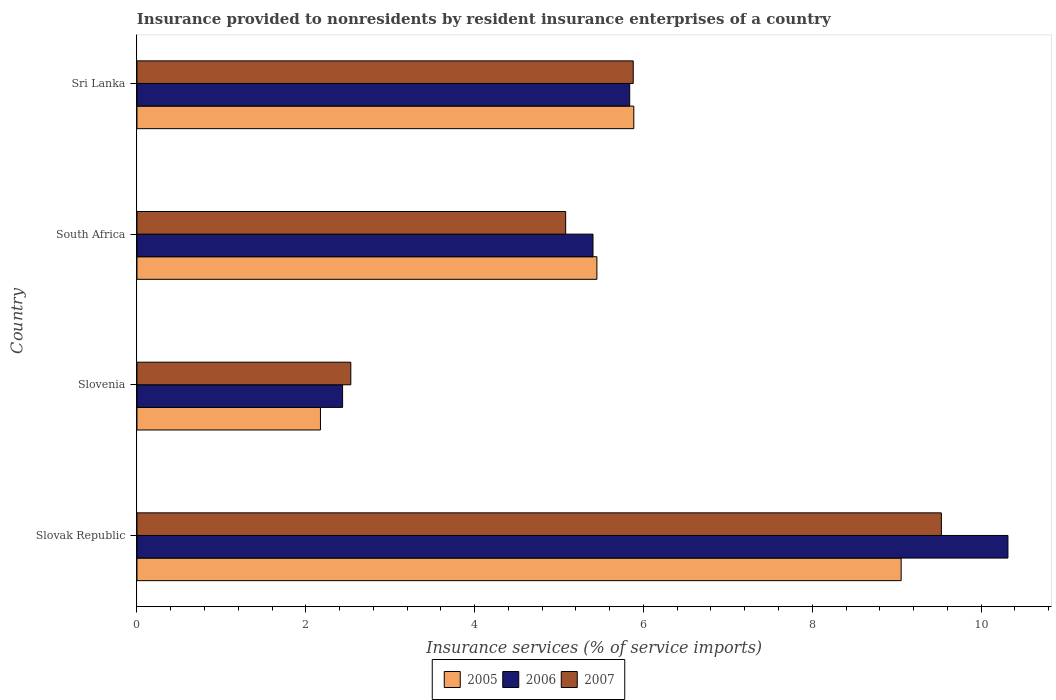How many groups of bars are there?
Your answer should be very brief. 4. How many bars are there on the 1st tick from the top?
Keep it short and to the point. 3. What is the label of the 4th group of bars from the top?
Your answer should be very brief. Slovak Republic. What is the insurance provided to nonresidents in 2006 in South Africa?
Keep it short and to the point. 5.4. Across all countries, what is the maximum insurance provided to nonresidents in 2005?
Offer a terse response. 9.05. Across all countries, what is the minimum insurance provided to nonresidents in 2005?
Make the answer very short. 2.17. In which country was the insurance provided to nonresidents in 2006 maximum?
Your response must be concise. Slovak Republic. In which country was the insurance provided to nonresidents in 2006 minimum?
Ensure brevity in your answer.  Slovenia. What is the total insurance provided to nonresidents in 2007 in the graph?
Keep it short and to the point. 23.02. What is the difference between the insurance provided to nonresidents in 2005 in Slovenia and that in South Africa?
Ensure brevity in your answer.  -3.27. What is the difference between the insurance provided to nonresidents in 2005 in Sri Lanka and the insurance provided to nonresidents in 2006 in South Africa?
Your answer should be compact. 0.48. What is the average insurance provided to nonresidents in 2005 per country?
Keep it short and to the point. 5.64. What is the difference between the insurance provided to nonresidents in 2006 and insurance provided to nonresidents in 2007 in South Africa?
Offer a terse response. 0.32. What is the ratio of the insurance provided to nonresidents in 2006 in Slovak Republic to that in South Africa?
Provide a succinct answer. 1.91. Is the insurance provided to nonresidents in 2006 in Slovenia less than that in South Africa?
Provide a succinct answer. Yes. What is the difference between the highest and the second highest insurance provided to nonresidents in 2006?
Offer a very short reply. 4.48. What is the difference between the highest and the lowest insurance provided to nonresidents in 2007?
Provide a succinct answer. 7. In how many countries, is the insurance provided to nonresidents in 2005 greater than the average insurance provided to nonresidents in 2005 taken over all countries?
Provide a short and direct response. 2. What does the 2nd bar from the top in Slovak Republic represents?
Offer a very short reply. 2006. What does the 3rd bar from the bottom in Slovenia represents?
Ensure brevity in your answer.  2007. Is it the case that in every country, the sum of the insurance provided to nonresidents in 2005 and insurance provided to nonresidents in 2006 is greater than the insurance provided to nonresidents in 2007?
Make the answer very short. Yes. How many bars are there?
Make the answer very short. 12. How many countries are there in the graph?
Provide a succinct answer. 4. Are the values on the major ticks of X-axis written in scientific E-notation?
Make the answer very short. No. Does the graph contain grids?
Give a very brief answer. No. Where does the legend appear in the graph?
Keep it short and to the point. Bottom center. How are the legend labels stacked?
Your answer should be very brief. Horizontal. What is the title of the graph?
Your answer should be compact. Insurance provided to nonresidents by resident insurance enterprises of a country. Does "2012" appear as one of the legend labels in the graph?
Your response must be concise. No. What is the label or title of the X-axis?
Provide a succinct answer. Insurance services (% of service imports). What is the Insurance services (% of service imports) of 2005 in Slovak Republic?
Your answer should be compact. 9.05. What is the Insurance services (% of service imports) of 2006 in Slovak Republic?
Keep it short and to the point. 10.32. What is the Insurance services (% of service imports) in 2007 in Slovak Republic?
Ensure brevity in your answer.  9.53. What is the Insurance services (% of service imports) of 2005 in Slovenia?
Provide a short and direct response. 2.17. What is the Insurance services (% of service imports) in 2006 in Slovenia?
Make the answer very short. 2.44. What is the Insurance services (% of service imports) of 2007 in Slovenia?
Your answer should be compact. 2.53. What is the Insurance services (% of service imports) in 2005 in South Africa?
Provide a short and direct response. 5.45. What is the Insurance services (% of service imports) in 2006 in South Africa?
Make the answer very short. 5.4. What is the Insurance services (% of service imports) in 2007 in South Africa?
Provide a short and direct response. 5.08. What is the Insurance services (% of service imports) in 2005 in Sri Lanka?
Provide a succinct answer. 5.89. What is the Insurance services (% of service imports) in 2006 in Sri Lanka?
Keep it short and to the point. 5.84. What is the Insurance services (% of service imports) of 2007 in Sri Lanka?
Give a very brief answer. 5.88. Across all countries, what is the maximum Insurance services (% of service imports) of 2005?
Ensure brevity in your answer.  9.05. Across all countries, what is the maximum Insurance services (% of service imports) in 2006?
Give a very brief answer. 10.32. Across all countries, what is the maximum Insurance services (% of service imports) in 2007?
Your answer should be very brief. 9.53. Across all countries, what is the minimum Insurance services (% of service imports) in 2005?
Your answer should be compact. 2.17. Across all countries, what is the minimum Insurance services (% of service imports) in 2006?
Keep it short and to the point. 2.44. Across all countries, what is the minimum Insurance services (% of service imports) of 2007?
Your response must be concise. 2.53. What is the total Insurance services (% of service imports) in 2005 in the graph?
Make the answer very short. 22.56. What is the total Insurance services (% of service imports) of 2006 in the graph?
Ensure brevity in your answer.  24. What is the total Insurance services (% of service imports) of 2007 in the graph?
Provide a short and direct response. 23.02. What is the difference between the Insurance services (% of service imports) in 2005 in Slovak Republic and that in Slovenia?
Your answer should be very brief. 6.88. What is the difference between the Insurance services (% of service imports) in 2006 in Slovak Republic and that in Slovenia?
Keep it short and to the point. 7.88. What is the difference between the Insurance services (% of service imports) in 2007 in Slovak Republic and that in Slovenia?
Give a very brief answer. 7. What is the difference between the Insurance services (% of service imports) in 2005 in Slovak Republic and that in South Africa?
Your answer should be very brief. 3.6. What is the difference between the Insurance services (% of service imports) in 2006 in Slovak Republic and that in South Africa?
Offer a very short reply. 4.92. What is the difference between the Insurance services (% of service imports) of 2007 in Slovak Republic and that in South Africa?
Your response must be concise. 4.45. What is the difference between the Insurance services (% of service imports) of 2005 in Slovak Republic and that in Sri Lanka?
Ensure brevity in your answer.  3.17. What is the difference between the Insurance services (% of service imports) of 2006 in Slovak Republic and that in Sri Lanka?
Ensure brevity in your answer.  4.48. What is the difference between the Insurance services (% of service imports) of 2007 in Slovak Republic and that in Sri Lanka?
Provide a short and direct response. 3.65. What is the difference between the Insurance services (% of service imports) of 2005 in Slovenia and that in South Africa?
Offer a terse response. -3.27. What is the difference between the Insurance services (% of service imports) in 2006 in Slovenia and that in South Africa?
Keep it short and to the point. -2.97. What is the difference between the Insurance services (% of service imports) in 2007 in Slovenia and that in South Africa?
Provide a succinct answer. -2.55. What is the difference between the Insurance services (% of service imports) of 2005 in Slovenia and that in Sri Lanka?
Offer a very short reply. -3.71. What is the difference between the Insurance services (% of service imports) of 2006 in Slovenia and that in Sri Lanka?
Ensure brevity in your answer.  -3.4. What is the difference between the Insurance services (% of service imports) of 2007 in Slovenia and that in Sri Lanka?
Your response must be concise. -3.35. What is the difference between the Insurance services (% of service imports) in 2005 in South Africa and that in Sri Lanka?
Provide a short and direct response. -0.44. What is the difference between the Insurance services (% of service imports) in 2006 in South Africa and that in Sri Lanka?
Give a very brief answer. -0.43. What is the difference between the Insurance services (% of service imports) of 2007 in South Africa and that in Sri Lanka?
Provide a succinct answer. -0.8. What is the difference between the Insurance services (% of service imports) in 2005 in Slovak Republic and the Insurance services (% of service imports) in 2006 in Slovenia?
Your answer should be very brief. 6.62. What is the difference between the Insurance services (% of service imports) in 2005 in Slovak Republic and the Insurance services (% of service imports) in 2007 in Slovenia?
Provide a short and direct response. 6.52. What is the difference between the Insurance services (% of service imports) in 2006 in Slovak Republic and the Insurance services (% of service imports) in 2007 in Slovenia?
Provide a short and direct response. 7.79. What is the difference between the Insurance services (% of service imports) in 2005 in Slovak Republic and the Insurance services (% of service imports) in 2006 in South Africa?
Provide a short and direct response. 3.65. What is the difference between the Insurance services (% of service imports) in 2005 in Slovak Republic and the Insurance services (% of service imports) in 2007 in South Africa?
Provide a short and direct response. 3.97. What is the difference between the Insurance services (% of service imports) in 2006 in Slovak Republic and the Insurance services (% of service imports) in 2007 in South Africa?
Your response must be concise. 5.24. What is the difference between the Insurance services (% of service imports) in 2005 in Slovak Republic and the Insurance services (% of service imports) in 2006 in Sri Lanka?
Provide a short and direct response. 3.22. What is the difference between the Insurance services (% of service imports) in 2005 in Slovak Republic and the Insurance services (% of service imports) in 2007 in Sri Lanka?
Give a very brief answer. 3.17. What is the difference between the Insurance services (% of service imports) in 2006 in Slovak Republic and the Insurance services (% of service imports) in 2007 in Sri Lanka?
Your response must be concise. 4.44. What is the difference between the Insurance services (% of service imports) of 2005 in Slovenia and the Insurance services (% of service imports) of 2006 in South Africa?
Your answer should be compact. -3.23. What is the difference between the Insurance services (% of service imports) in 2005 in Slovenia and the Insurance services (% of service imports) in 2007 in South Africa?
Offer a very short reply. -2.9. What is the difference between the Insurance services (% of service imports) in 2006 in Slovenia and the Insurance services (% of service imports) in 2007 in South Africa?
Ensure brevity in your answer.  -2.64. What is the difference between the Insurance services (% of service imports) of 2005 in Slovenia and the Insurance services (% of service imports) of 2006 in Sri Lanka?
Keep it short and to the point. -3.66. What is the difference between the Insurance services (% of service imports) in 2005 in Slovenia and the Insurance services (% of service imports) in 2007 in Sri Lanka?
Your answer should be compact. -3.71. What is the difference between the Insurance services (% of service imports) of 2006 in Slovenia and the Insurance services (% of service imports) of 2007 in Sri Lanka?
Your response must be concise. -3.44. What is the difference between the Insurance services (% of service imports) of 2005 in South Africa and the Insurance services (% of service imports) of 2006 in Sri Lanka?
Offer a terse response. -0.39. What is the difference between the Insurance services (% of service imports) of 2005 in South Africa and the Insurance services (% of service imports) of 2007 in Sri Lanka?
Make the answer very short. -0.43. What is the difference between the Insurance services (% of service imports) of 2006 in South Africa and the Insurance services (% of service imports) of 2007 in Sri Lanka?
Give a very brief answer. -0.48. What is the average Insurance services (% of service imports) of 2005 per country?
Your response must be concise. 5.64. What is the average Insurance services (% of service imports) in 2006 per country?
Your answer should be compact. 6. What is the average Insurance services (% of service imports) in 2007 per country?
Ensure brevity in your answer.  5.76. What is the difference between the Insurance services (% of service imports) in 2005 and Insurance services (% of service imports) in 2006 in Slovak Republic?
Make the answer very short. -1.27. What is the difference between the Insurance services (% of service imports) of 2005 and Insurance services (% of service imports) of 2007 in Slovak Republic?
Your answer should be very brief. -0.48. What is the difference between the Insurance services (% of service imports) in 2006 and Insurance services (% of service imports) in 2007 in Slovak Republic?
Keep it short and to the point. 0.79. What is the difference between the Insurance services (% of service imports) in 2005 and Insurance services (% of service imports) in 2006 in Slovenia?
Your answer should be compact. -0.26. What is the difference between the Insurance services (% of service imports) in 2005 and Insurance services (% of service imports) in 2007 in Slovenia?
Keep it short and to the point. -0.36. What is the difference between the Insurance services (% of service imports) in 2006 and Insurance services (% of service imports) in 2007 in Slovenia?
Make the answer very short. -0.1. What is the difference between the Insurance services (% of service imports) in 2005 and Insurance services (% of service imports) in 2006 in South Africa?
Your answer should be very brief. 0.05. What is the difference between the Insurance services (% of service imports) of 2005 and Insurance services (% of service imports) of 2007 in South Africa?
Make the answer very short. 0.37. What is the difference between the Insurance services (% of service imports) of 2006 and Insurance services (% of service imports) of 2007 in South Africa?
Your answer should be very brief. 0.32. What is the difference between the Insurance services (% of service imports) in 2005 and Insurance services (% of service imports) in 2006 in Sri Lanka?
Your answer should be compact. 0.05. What is the difference between the Insurance services (% of service imports) of 2005 and Insurance services (% of service imports) of 2007 in Sri Lanka?
Offer a very short reply. 0.01. What is the difference between the Insurance services (% of service imports) in 2006 and Insurance services (% of service imports) in 2007 in Sri Lanka?
Ensure brevity in your answer.  -0.04. What is the ratio of the Insurance services (% of service imports) in 2005 in Slovak Republic to that in Slovenia?
Your answer should be compact. 4.16. What is the ratio of the Insurance services (% of service imports) in 2006 in Slovak Republic to that in Slovenia?
Make the answer very short. 4.24. What is the ratio of the Insurance services (% of service imports) of 2007 in Slovak Republic to that in Slovenia?
Offer a terse response. 3.76. What is the ratio of the Insurance services (% of service imports) in 2005 in Slovak Republic to that in South Africa?
Provide a succinct answer. 1.66. What is the ratio of the Insurance services (% of service imports) in 2006 in Slovak Republic to that in South Africa?
Give a very brief answer. 1.91. What is the ratio of the Insurance services (% of service imports) of 2007 in Slovak Republic to that in South Africa?
Offer a very short reply. 1.88. What is the ratio of the Insurance services (% of service imports) of 2005 in Slovak Republic to that in Sri Lanka?
Give a very brief answer. 1.54. What is the ratio of the Insurance services (% of service imports) in 2006 in Slovak Republic to that in Sri Lanka?
Keep it short and to the point. 1.77. What is the ratio of the Insurance services (% of service imports) in 2007 in Slovak Republic to that in Sri Lanka?
Your response must be concise. 1.62. What is the ratio of the Insurance services (% of service imports) in 2005 in Slovenia to that in South Africa?
Ensure brevity in your answer.  0.4. What is the ratio of the Insurance services (% of service imports) in 2006 in Slovenia to that in South Africa?
Provide a succinct answer. 0.45. What is the ratio of the Insurance services (% of service imports) of 2007 in Slovenia to that in South Africa?
Ensure brevity in your answer.  0.5. What is the ratio of the Insurance services (% of service imports) of 2005 in Slovenia to that in Sri Lanka?
Offer a very short reply. 0.37. What is the ratio of the Insurance services (% of service imports) in 2006 in Slovenia to that in Sri Lanka?
Your response must be concise. 0.42. What is the ratio of the Insurance services (% of service imports) in 2007 in Slovenia to that in Sri Lanka?
Keep it short and to the point. 0.43. What is the ratio of the Insurance services (% of service imports) of 2005 in South Africa to that in Sri Lanka?
Give a very brief answer. 0.93. What is the ratio of the Insurance services (% of service imports) in 2006 in South Africa to that in Sri Lanka?
Keep it short and to the point. 0.93. What is the ratio of the Insurance services (% of service imports) of 2007 in South Africa to that in Sri Lanka?
Offer a terse response. 0.86. What is the difference between the highest and the second highest Insurance services (% of service imports) of 2005?
Ensure brevity in your answer.  3.17. What is the difference between the highest and the second highest Insurance services (% of service imports) of 2006?
Your response must be concise. 4.48. What is the difference between the highest and the second highest Insurance services (% of service imports) of 2007?
Provide a succinct answer. 3.65. What is the difference between the highest and the lowest Insurance services (% of service imports) of 2005?
Make the answer very short. 6.88. What is the difference between the highest and the lowest Insurance services (% of service imports) of 2006?
Give a very brief answer. 7.88. What is the difference between the highest and the lowest Insurance services (% of service imports) in 2007?
Make the answer very short. 7. 